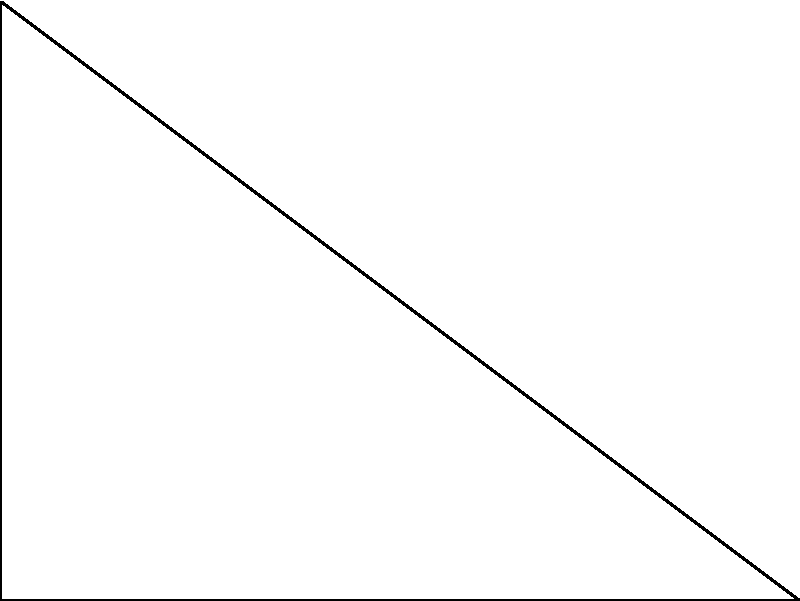A hijab-friendly sports headband needs to be designed to stay secure during vigorous activities. The optimal angle for the headband's curvature is represented by $\theta$ in the diagram. If the height of the headband is 3 cm and the width is 4 cm, what is the value of $\theta$ in degrees that provides the best fit and stability? To find the optimal angle $\theta$, we can use trigonometry in the right-angled triangle OAB:

1) First, we identify that we have a right-angled triangle with the following measurements:
   - The opposite side (OA) = 3 cm
   - The adjacent side (OB) = 4 cm

2) To find the angle $\theta$, we can use the arctangent function (tan^(-1) or atan):

   $\theta = \tan^{-1}(\frac{\text{opposite}}{\text{adjacent}})$

3) Substituting our values:

   $\theta = \tan^{-1}(\frac{3}{4})$

4) Using a calculator or computer:

   $\theta \approx 36.87°$

5) Rounding to the nearest degree:

   $\theta \approx 37°$

This angle provides an optimal curvature for the headband, balancing stability and comfort for the hijabi athlete during various activities.
Answer: $37°$ 